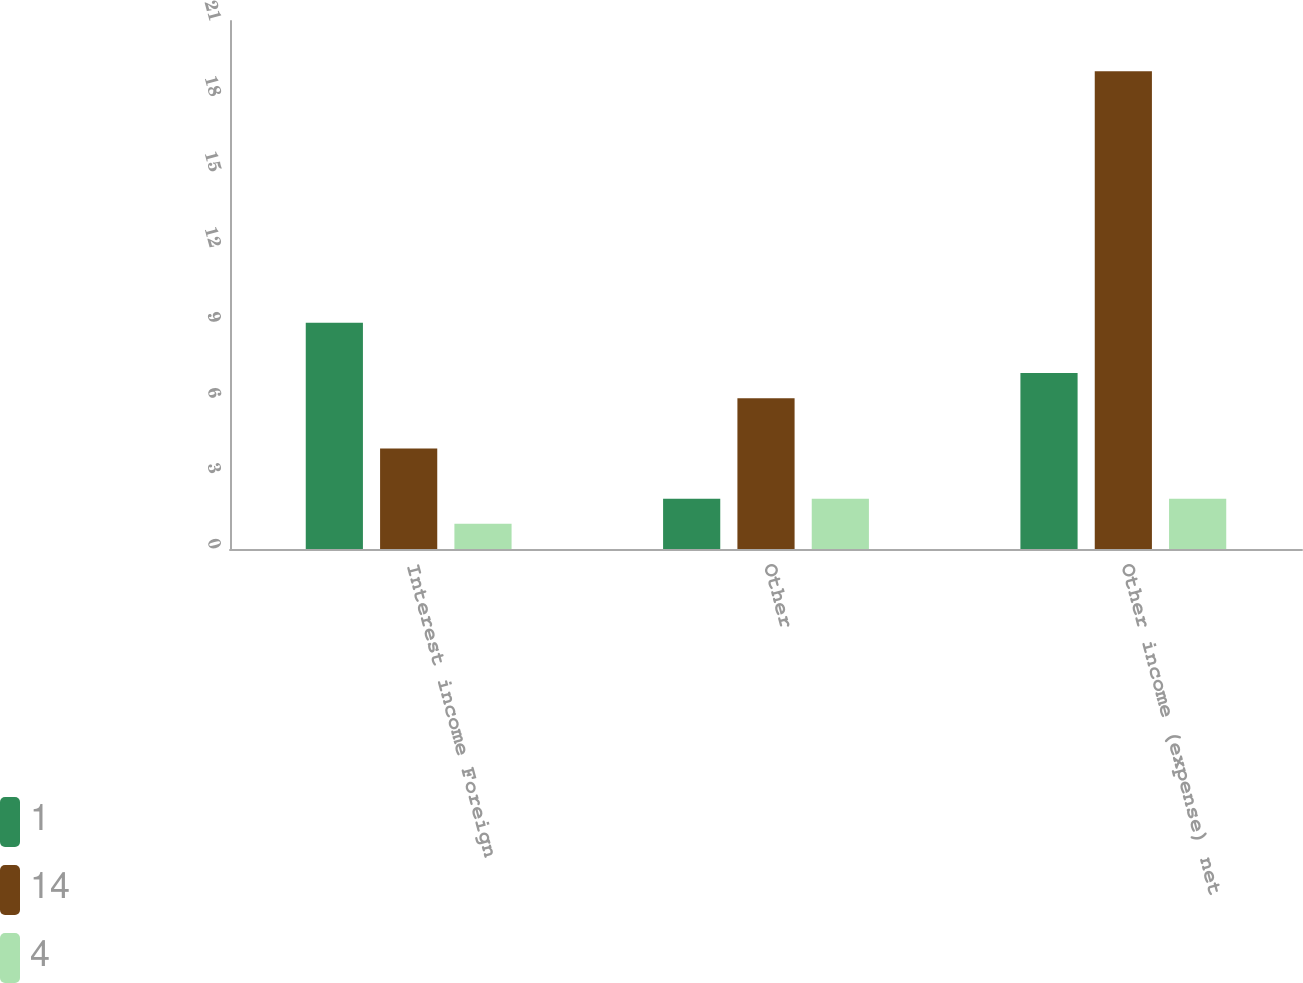Convert chart. <chart><loc_0><loc_0><loc_500><loc_500><stacked_bar_chart><ecel><fcel>Interest income Foreign<fcel>Other<fcel>Other income (expense) net<nl><fcel>1<fcel>9<fcel>2<fcel>7<nl><fcel>14<fcel>4<fcel>6<fcel>19<nl><fcel>4<fcel>1<fcel>2<fcel>2<nl></chart> 